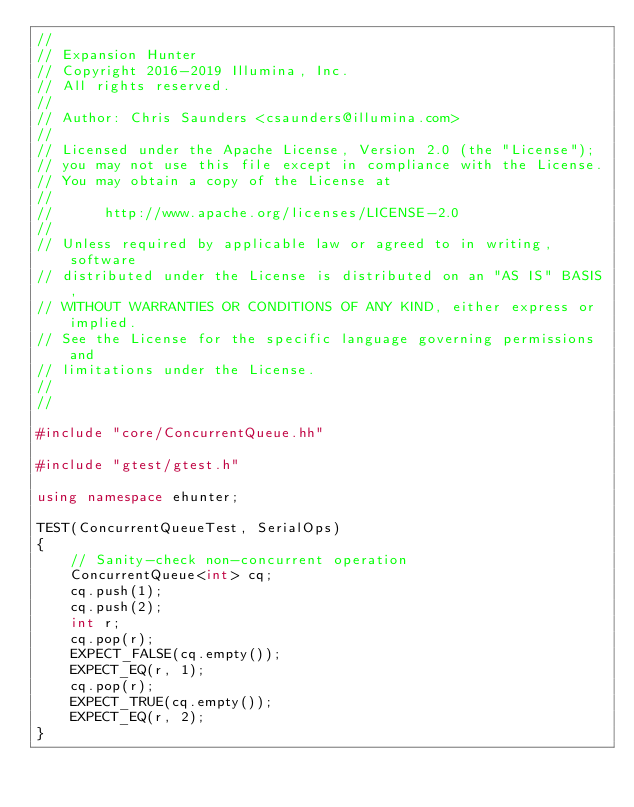Convert code to text. <code><loc_0><loc_0><loc_500><loc_500><_C++_>//
// Expansion Hunter
// Copyright 2016-2019 Illumina, Inc.
// All rights reserved.
//
// Author: Chris Saunders <csaunders@illumina.com>
//
// Licensed under the Apache License, Version 2.0 (the "License");
// you may not use this file except in compliance with the License.
// You may obtain a copy of the License at
//
//      http://www.apache.org/licenses/LICENSE-2.0
//
// Unless required by applicable law or agreed to in writing, software
// distributed under the License is distributed on an "AS IS" BASIS,
// WITHOUT WARRANTIES OR CONDITIONS OF ANY KIND, either express or implied.
// See the License for the specific language governing permissions and
// limitations under the License.
//
//

#include "core/ConcurrentQueue.hh"

#include "gtest/gtest.h"

using namespace ehunter;

TEST(ConcurrentQueueTest, SerialOps)
{
    // Sanity-check non-concurrent operation
    ConcurrentQueue<int> cq;
    cq.push(1);
    cq.push(2);
    int r;
    cq.pop(r);
    EXPECT_FALSE(cq.empty());
    EXPECT_EQ(r, 1);
    cq.pop(r);
    EXPECT_TRUE(cq.empty());
    EXPECT_EQ(r, 2);
}
</code> 